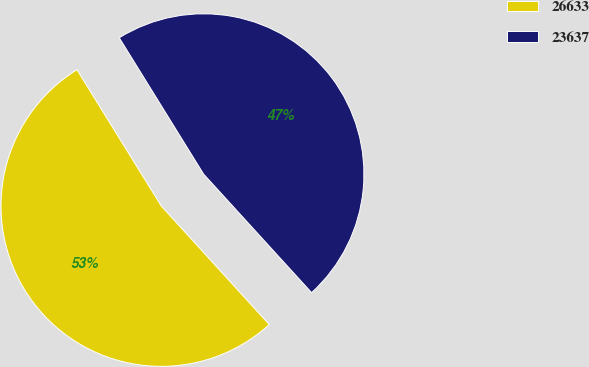Convert chart. <chart><loc_0><loc_0><loc_500><loc_500><pie_chart><fcel>26633<fcel>23637<nl><fcel>52.94%<fcel>47.06%<nl></chart> 